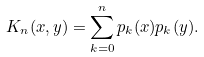Convert formula to latex. <formula><loc_0><loc_0><loc_500><loc_500>K _ { n } ( x , y ) = \sum _ { k = 0 } ^ { n } p _ { k } ( x ) p _ { k } ( y ) .</formula> 